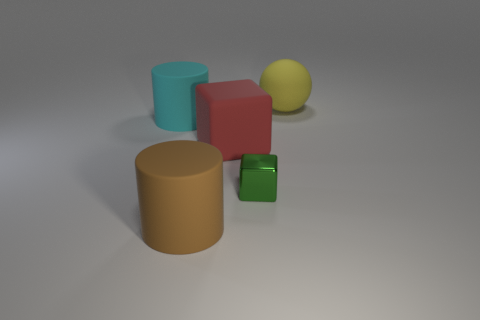There is another red thing that is the same shape as the shiny thing; what is it made of?
Offer a very short reply. Rubber. There is a large matte cylinder in front of the cyan matte cylinder; is there a yellow ball that is to the left of it?
Make the answer very short. No. There is a red block; are there any tiny things behind it?
Your answer should be very brief. No. Does the big object to the left of the brown rubber cylinder have the same shape as the red matte thing?
Offer a terse response. No. How many large objects have the same shape as the tiny green object?
Ensure brevity in your answer.  1. Is there a large cyan thing that has the same material as the green thing?
Provide a short and direct response. No. The object behind the big cylinder behind the large red block is made of what material?
Offer a very short reply. Rubber. How big is the cylinder in front of the rubber cube?
Keep it short and to the point. Large. There is a large ball; is it the same color as the big rubber cylinder behind the green cube?
Ensure brevity in your answer.  No. Are there any shiny blocks that have the same color as the big ball?
Provide a short and direct response. No. 